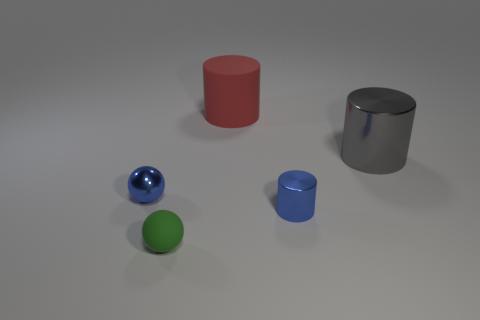Subtract all large gray metal cylinders. How many cylinders are left? 2 Add 2 blue balls. How many objects exist? 7 Subtract 1 cylinders. How many cylinders are left? 2 Subtract all spheres. How many objects are left? 3 Subtract all brown cylinders. Subtract all blue balls. How many cylinders are left? 3 Subtract all tiny green rubber objects. Subtract all small blue things. How many objects are left? 2 Add 4 big things. How many big things are left? 6 Add 1 small brown shiny cubes. How many small brown shiny cubes exist? 1 Subtract 0 red cubes. How many objects are left? 5 